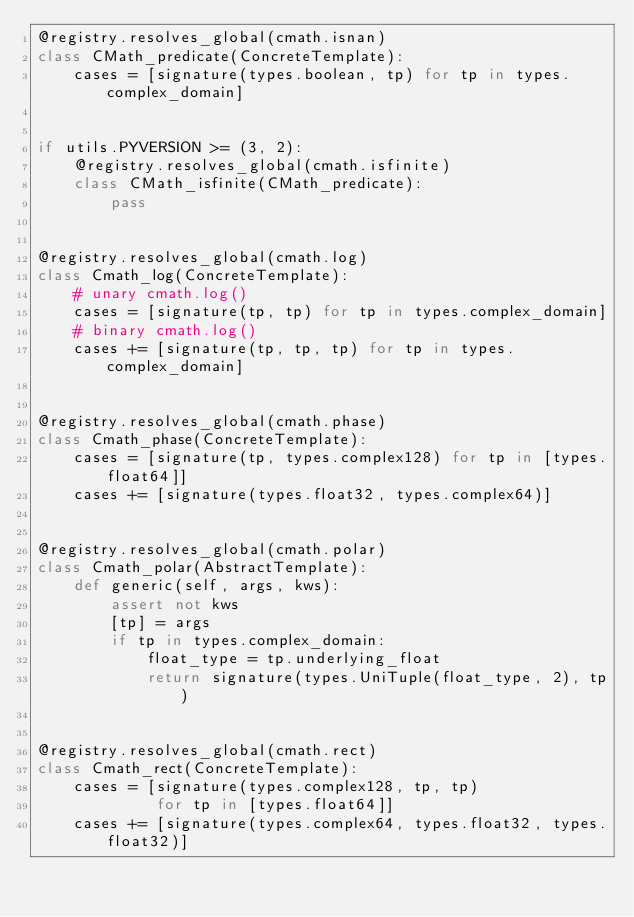Convert code to text. <code><loc_0><loc_0><loc_500><loc_500><_Python_>@registry.resolves_global(cmath.isnan)
class CMath_predicate(ConcreteTemplate):
    cases = [signature(types.boolean, tp) for tp in types.complex_domain]


if utils.PYVERSION >= (3, 2):
    @registry.resolves_global(cmath.isfinite)
    class CMath_isfinite(CMath_predicate):
        pass


@registry.resolves_global(cmath.log)
class Cmath_log(ConcreteTemplate):
    # unary cmath.log()
    cases = [signature(tp, tp) for tp in types.complex_domain]
    # binary cmath.log()
    cases += [signature(tp, tp, tp) for tp in types.complex_domain]


@registry.resolves_global(cmath.phase)
class Cmath_phase(ConcreteTemplate):
    cases = [signature(tp, types.complex128) for tp in [types.float64]]
    cases += [signature(types.float32, types.complex64)]


@registry.resolves_global(cmath.polar)
class Cmath_polar(AbstractTemplate):
    def generic(self, args, kws):
        assert not kws
        [tp] = args
        if tp in types.complex_domain:
            float_type = tp.underlying_float
            return signature(types.UniTuple(float_type, 2), tp)


@registry.resolves_global(cmath.rect)
class Cmath_rect(ConcreteTemplate):
    cases = [signature(types.complex128, tp, tp)
             for tp in [types.float64]]
    cases += [signature(types.complex64, types.float32, types.float32)]

</code> 